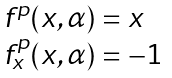Convert formula to latex. <formula><loc_0><loc_0><loc_500><loc_500>\begin{array} [ c ] { l } { f } ^ { p } ( x , \alpha ) = x \\ { f } _ { x } ^ { p } ( x , \alpha ) = - 1 \end{array}</formula> 